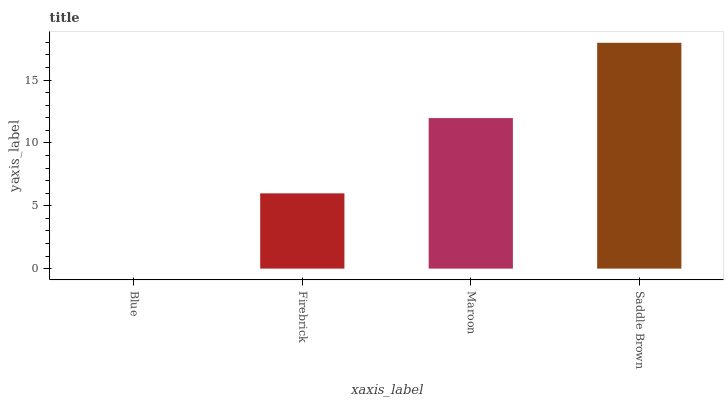Is Blue the minimum?
Answer yes or no. Yes. Is Saddle Brown the maximum?
Answer yes or no. Yes. Is Firebrick the minimum?
Answer yes or no. No. Is Firebrick the maximum?
Answer yes or no. No. Is Firebrick greater than Blue?
Answer yes or no. Yes. Is Blue less than Firebrick?
Answer yes or no. Yes. Is Blue greater than Firebrick?
Answer yes or no. No. Is Firebrick less than Blue?
Answer yes or no. No. Is Maroon the high median?
Answer yes or no. Yes. Is Firebrick the low median?
Answer yes or no. Yes. Is Blue the high median?
Answer yes or no. No. Is Saddle Brown the low median?
Answer yes or no. No. 